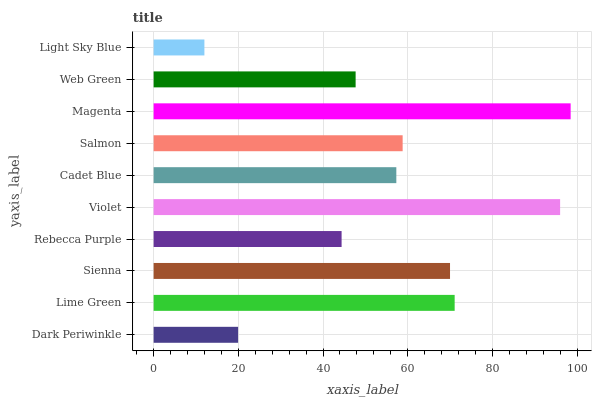Is Light Sky Blue the minimum?
Answer yes or no. Yes. Is Magenta the maximum?
Answer yes or no. Yes. Is Lime Green the minimum?
Answer yes or no. No. Is Lime Green the maximum?
Answer yes or no. No. Is Lime Green greater than Dark Periwinkle?
Answer yes or no. Yes. Is Dark Periwinkle less than Lime Green?
Answer yes or no. Yes. Is Dark Periwinkle greater than Lime Green?
Answer yes or no. No. Is Lime Green less than Dark Periwinkle?
Answer yes or no. No. Is Salmon the high median?
Answer yes or no. Yes. Is Cadet Blue the low median?
Answer yes or no. Yes. Is Web Green the high median?
Answer yes or no. No. Is Web Green the low median?
Answer yes or no. No. 